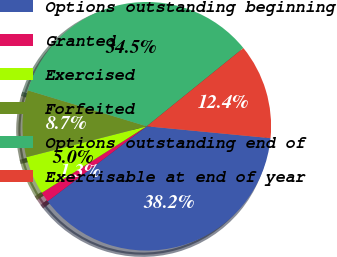<chart> <loc_0><loc_0><loc_500><loc_500><pie_chart><fcel>Options outstanding beginning<fcel>Granted<fcel>Exercised<fcel>Forfeited<fcel>Options outstanding end of<fcel>Exercisable at end of year<nl><fcel>38.17%<fcel>1.32%<fcel>4.99%<fcel>8.67%<fcel>34.5%<fcel>12.35%<nl></chart> 